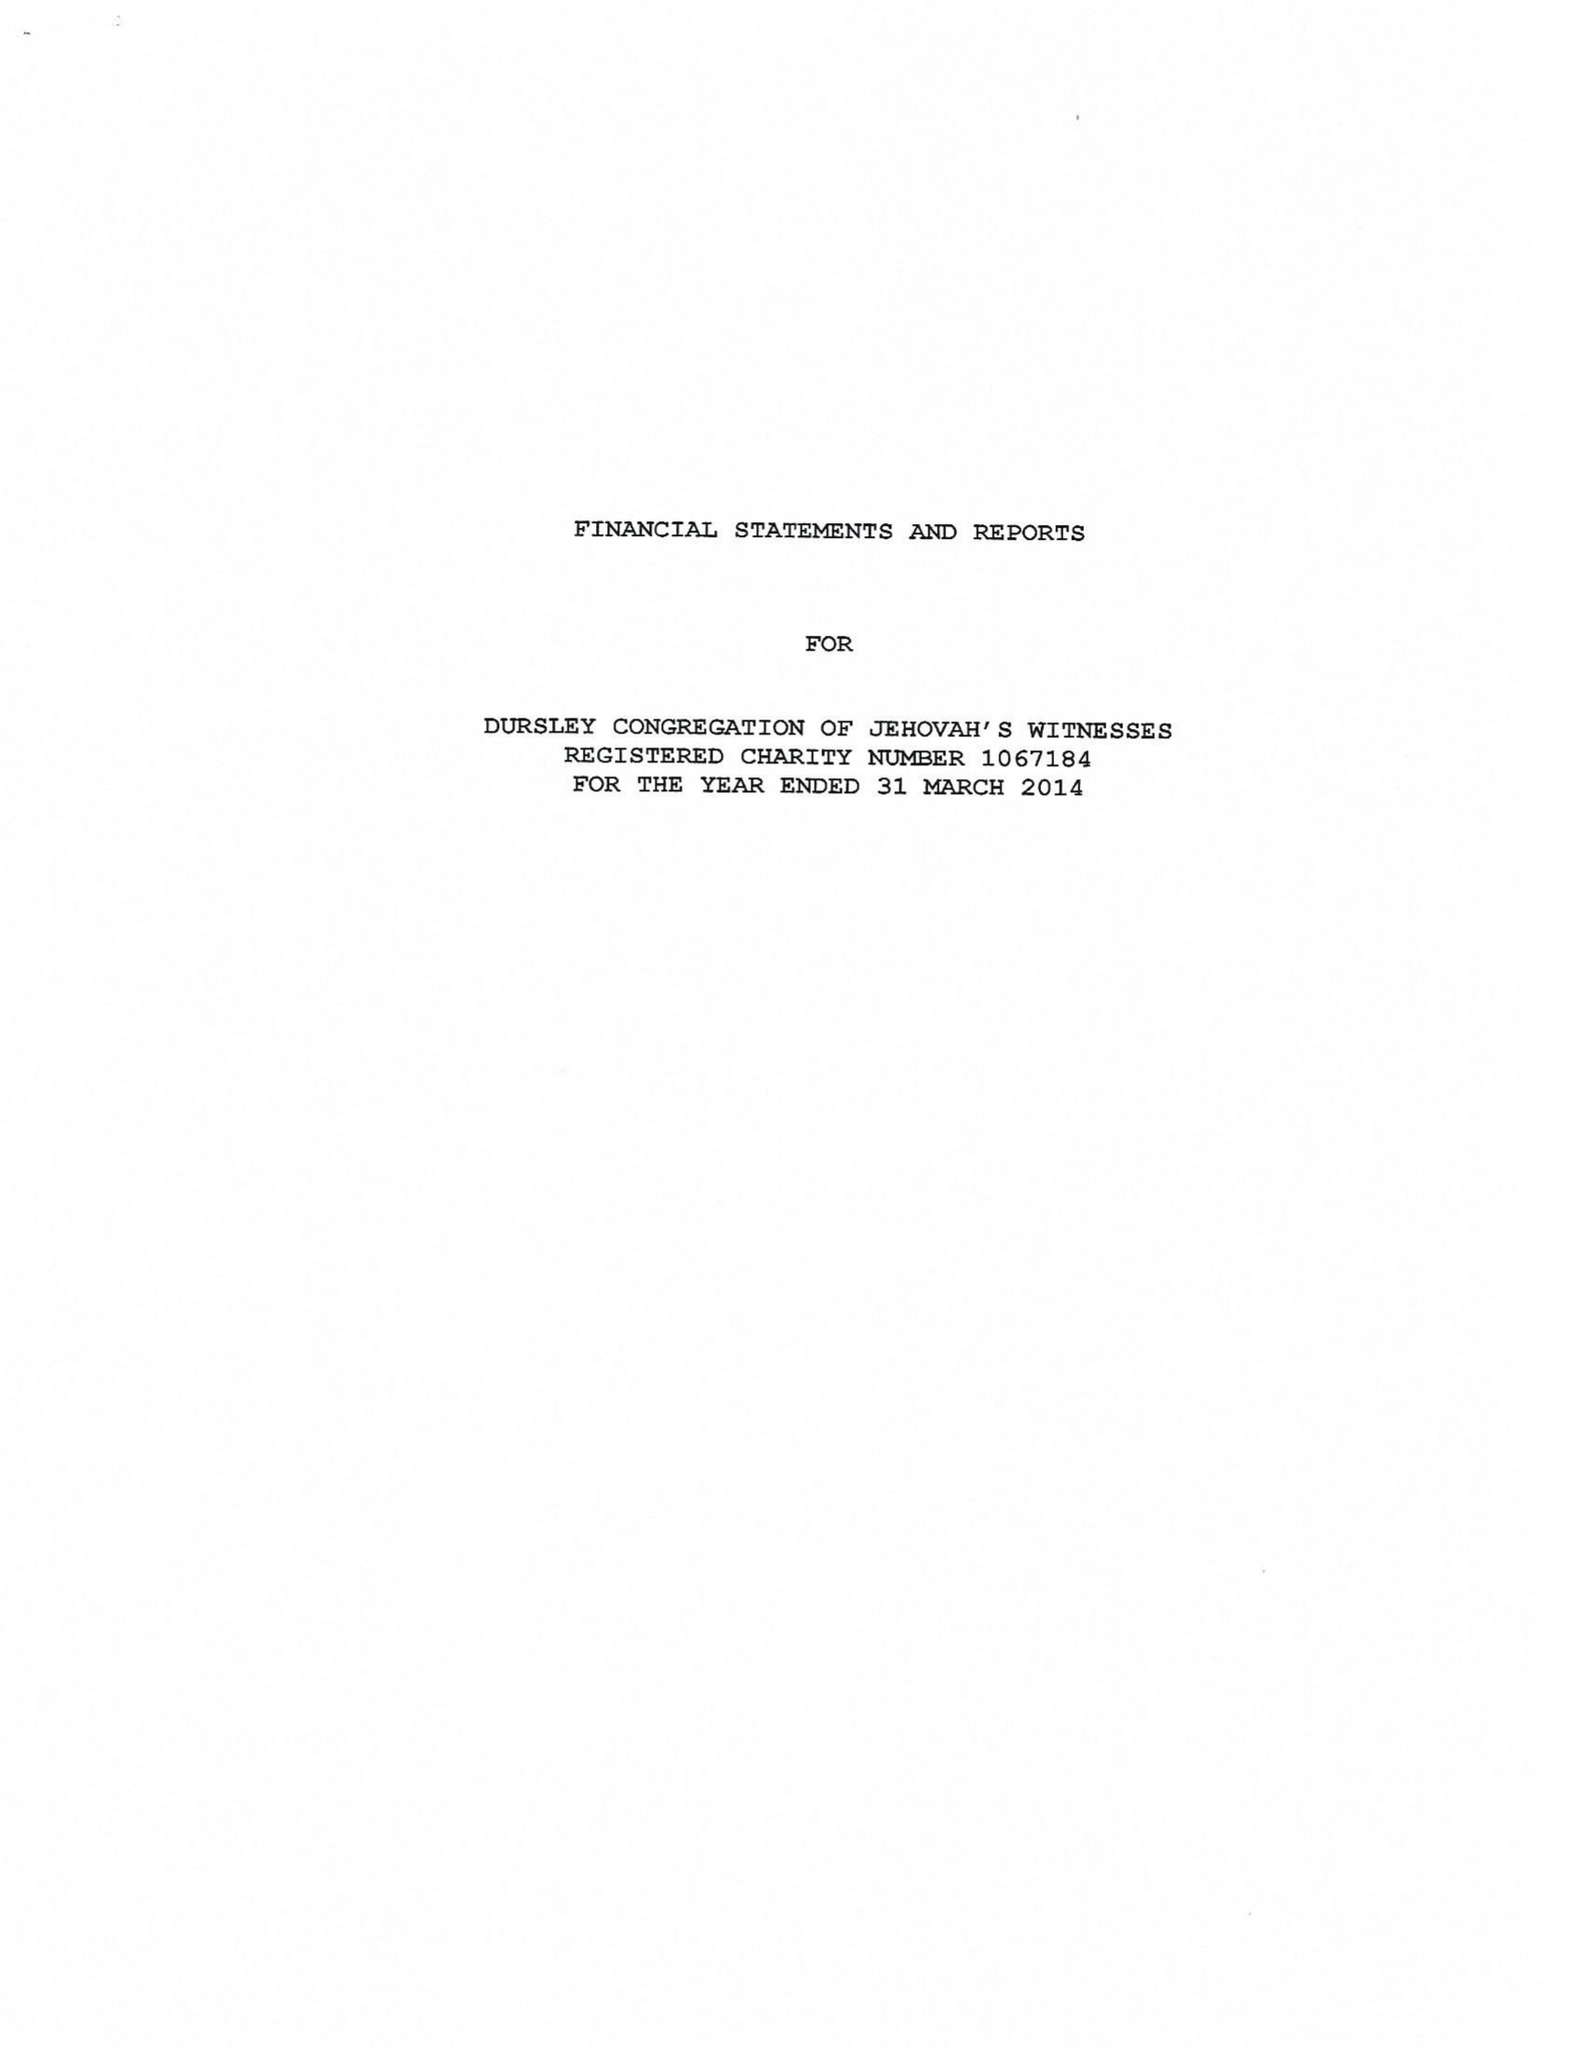What is the value for the income_annually_in_british_pounds?
Answer the question using a single word or phrase. 31239.00 